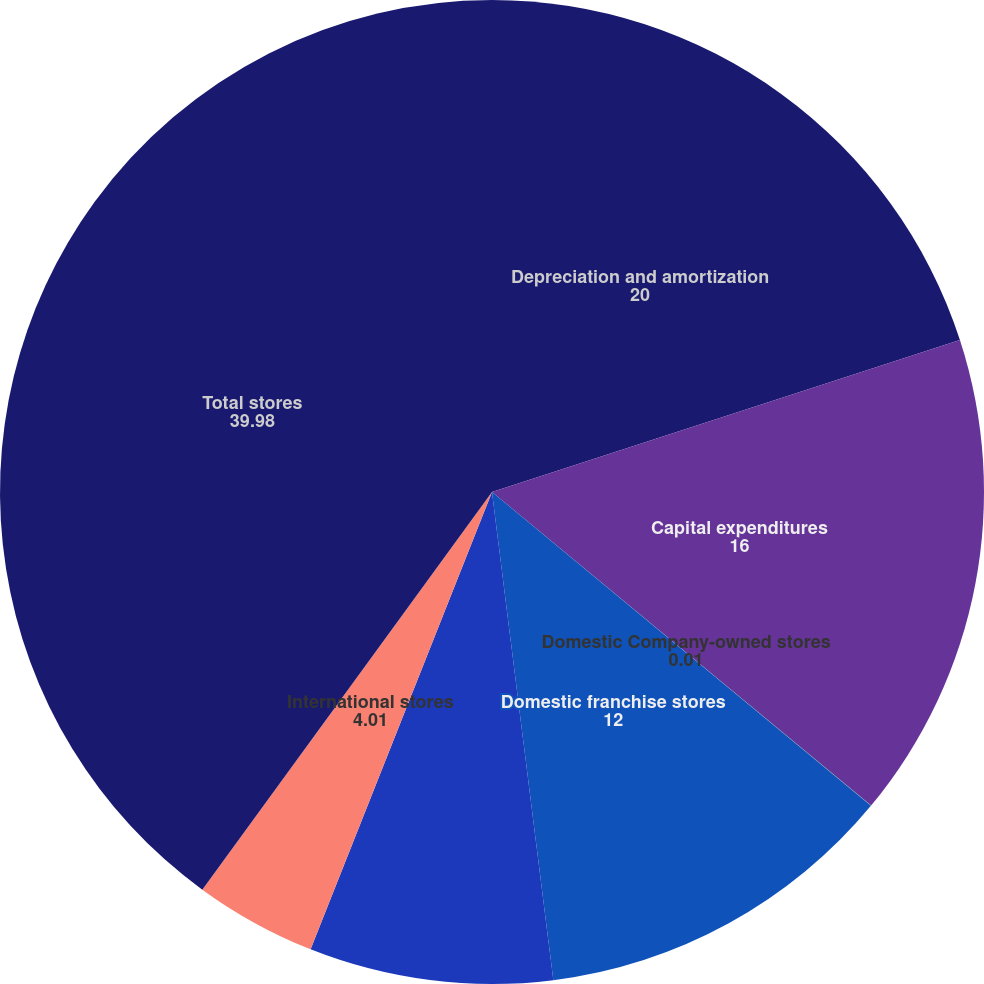<chart> <loc_0><loc_0><loc_500><loc_500><pie_chart><fcel>Depreciation and amortization<fcel>Capital expenditures<fcel>Domestic Company-owned stores<fcel>Domestic franchise stores<fcel>Domestic stores<fcel>International stores<fcel>Total stores<nl><fcel>20.0%<fcel>16.0%<fcel>0.01%<fcel>12.0%<fcel>8.0%<fcel>4.01%<fcel>39.98%<nl></chart> 